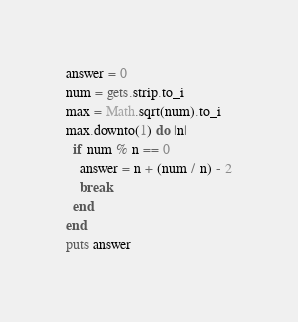<code> <loc_0><loc_0><loc_500><loc_500><_Ruby_>answer = 0
num = gets.strip.to_i
max = Math.sqrt(num).to_i
max.downto(1) do |n|
  if num % n == 0
    answer = n + (num / n) - 2
    break
  end
end
puts answer</code> 